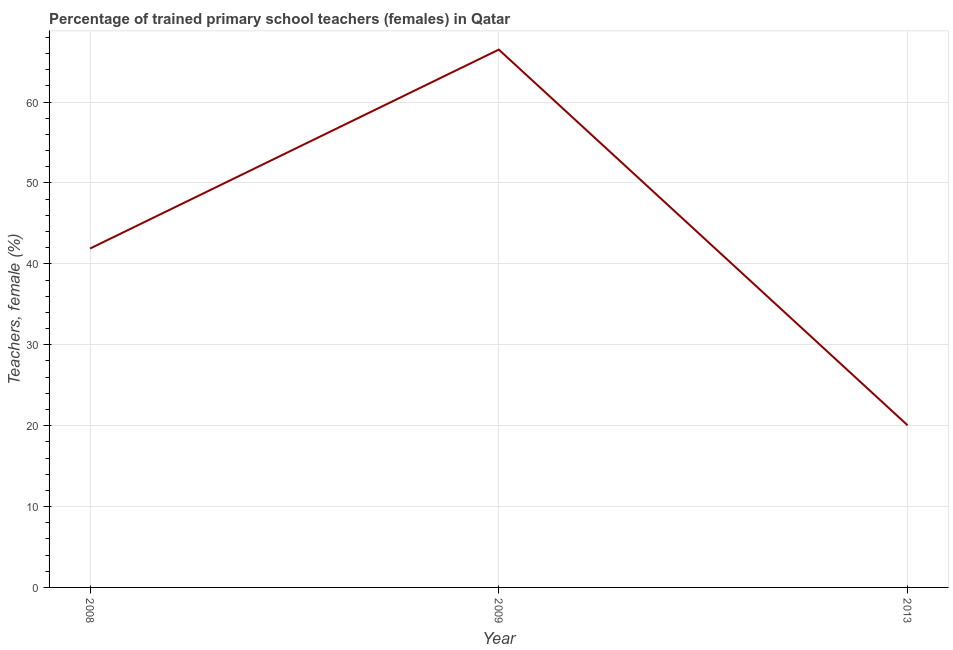What is the percentage of trained female teachers in 2008?
Provide a short and direct response. 41.89. Across all years, what is the maximum percentage of trained female teachers?
Give a very brief answer. 66.49. Across all years, what is the minimum percentage of trained female teachers?
Provide a succinct answer. 20.04. In which year was the percentage of trained female teachers maximum?
Keep it short and to the point. 2009. In which year was the percentage of trained female teachers minimum?
Give a very brief answer. 2013. What is the sum of the percentage of trained female teachers?
Offer a terse response. 128.43. What is the difference between the percentage of trained female teachers in 2008 and 2009?
Your answer should be compact. -24.59. What is the average percentage of trained female teachers per year?
Your answer should be compact. 42.81. What is the median percentage of trained female teachers?
Offer a terse response. 41.89. Do a majority of the years between 2013 and 2009 (inclusive) have percentage of trained female teachers greater than 2 %?
Provide a succinct answer. No. What is the ratio of the percentage of trained female teachers in 2009 to that in 2013?
Your response must be concise. 3.32. Is the difference between the percentage of trained female teachers in 2008 and 2013 greater than the difference between any two years?
Provide a short and direct response. No. What is the difference between the highest and the second highest percentage of trained female teachers?
Your response must be concise. 24.59. Is the sum of the percentage of trained female teachers in 2009 and 2013 greater than the maximum percentage of trained female teachers across all years?
Ensure brevity in your answer.  Yes. What is the difference between the highest and the lowest percentage of trained female teachers?
Give a very brief answer. 46.44. What is the difference between two consecutive major ticks on the Y-axis?
Ensure brevity in your answer.  10. What is the title of the graph?
Keep it short and to the point. Percentage of trained primary school teachers (females) in Qatar. What is the label or title of the X-axis?
Give a very brief answer. Year. What is the label or title of the Y-axis?
Provide a short and direct response. Teachers, female (%). What is the Teachers, female (%) in 2008?
Ensure brevity in your answer.  41.89. What is the Teachers, female (%) of 2009?
Ensure brevity in your answer.  66.49. What is the Teachers, female (%) in 2013?
Make the answer very short. 20.04. What is the difference between the Teachers, female (%) in 2008 and 2009?
Keep it short and to the point. -24.59. What is the difference between the Teachers, female (%) in 2008 and 2013?
Provide a short and direct response. 21.85. What is the difference between the Teachers, female (%) in 2009 and 2013?
Provide a short and direct response. 46.44. What is the ratio of the Teachers, female (%) in 2008 to that in 2009?
Give a very brief answer. 0.63. What is the ratio of the Teachers, female (%) in 2008 to that in 2013?
Offer a very short reply. 2.09. What is the ratio of the Teachers, female (%) in 2009 to that in 2013?
Offer a terse response. 3.32. 